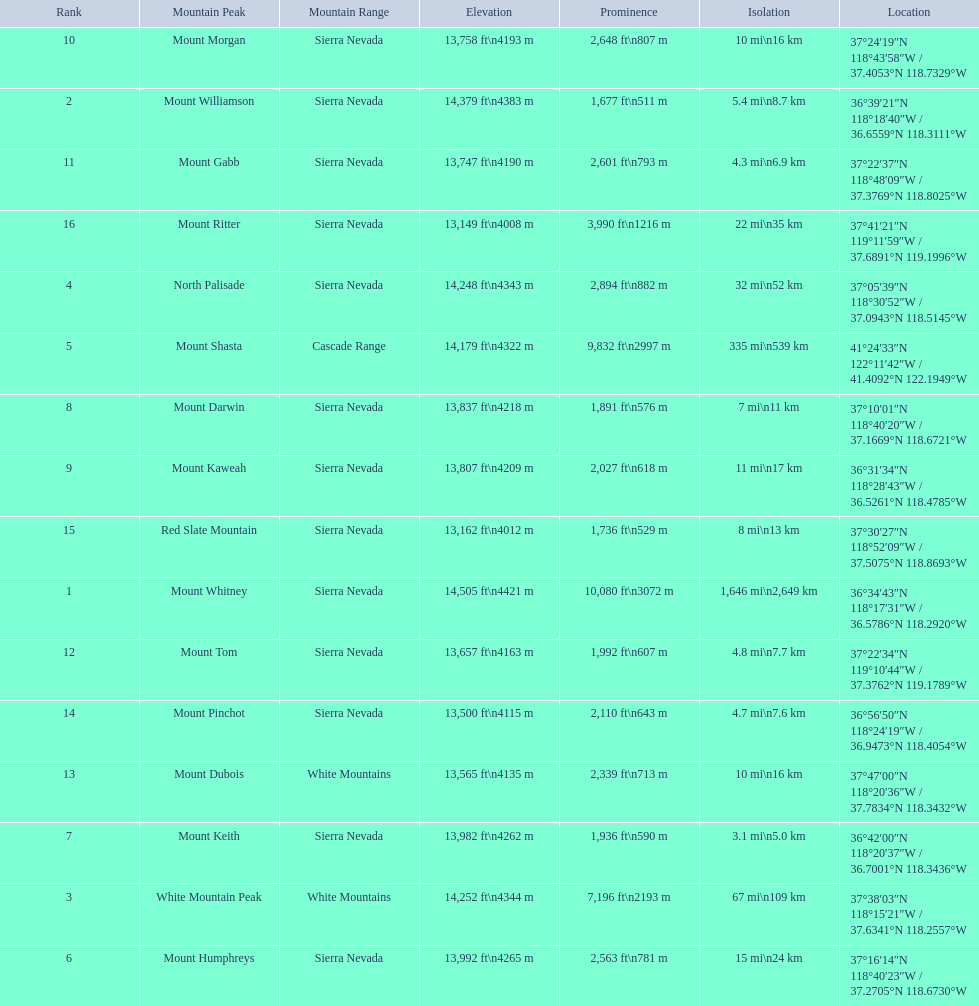What are the heights of the peaks? 14,505 ft\n4421 m, 14,379 ft\n4383 m, 14,252 ft\n4344 m, 14,248 ft\n4343 m, 14,179 ft\n4322 m, 13,992 ft\n4265 m, 13,982 ft\n4262 m, 13,837 ft\n4218 m, 13,807 ft\n4209 m, 13,758 ft\n4193 m, 13,747 ft\n4190 m, 13,657 ft\n4163 m, 13,565 ft\n4135 m, 13,500 ft\n4115 m, 13,162 ft\n4012 m, 13,149 ft\n4008 m. Which of these heights is tallest? 14,505 ft\n4421 m. What peak is 14,505 feet? Mount Whitney. 